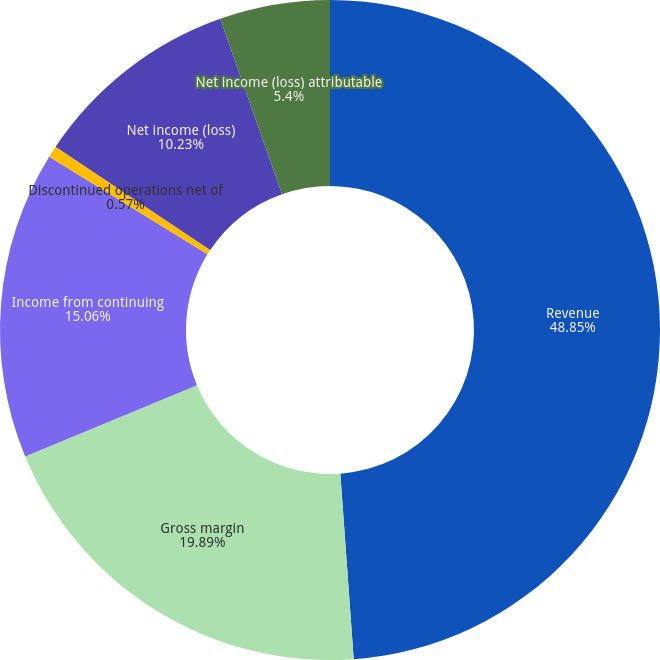Convert chart. <chart><loc_0><loc_0><loc_500><loc_500><pie_chart><fcel>Revenue<fcel>Gross margin<fcel>Income from continuing<fcel>Discontinued operations net of<fcel>Net income (loss)<fcel>Net income (loss) attributable<nl><fcel>48.86%<fcel>19.89%<fcel>15.06%<fcel>0.57%<fcel>10.23%<fcel>5.4%<nl></chart> 